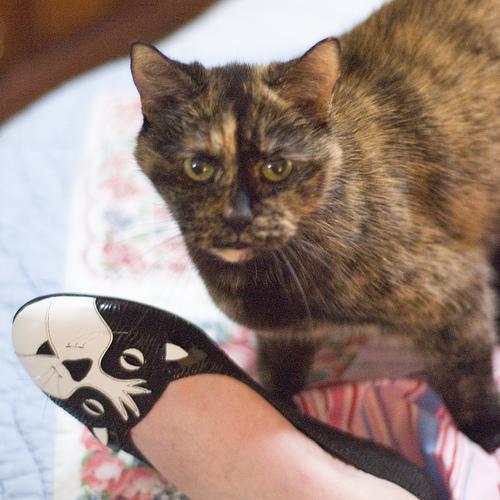How many cats are in the photo?
Give a very brief answer. 1. 